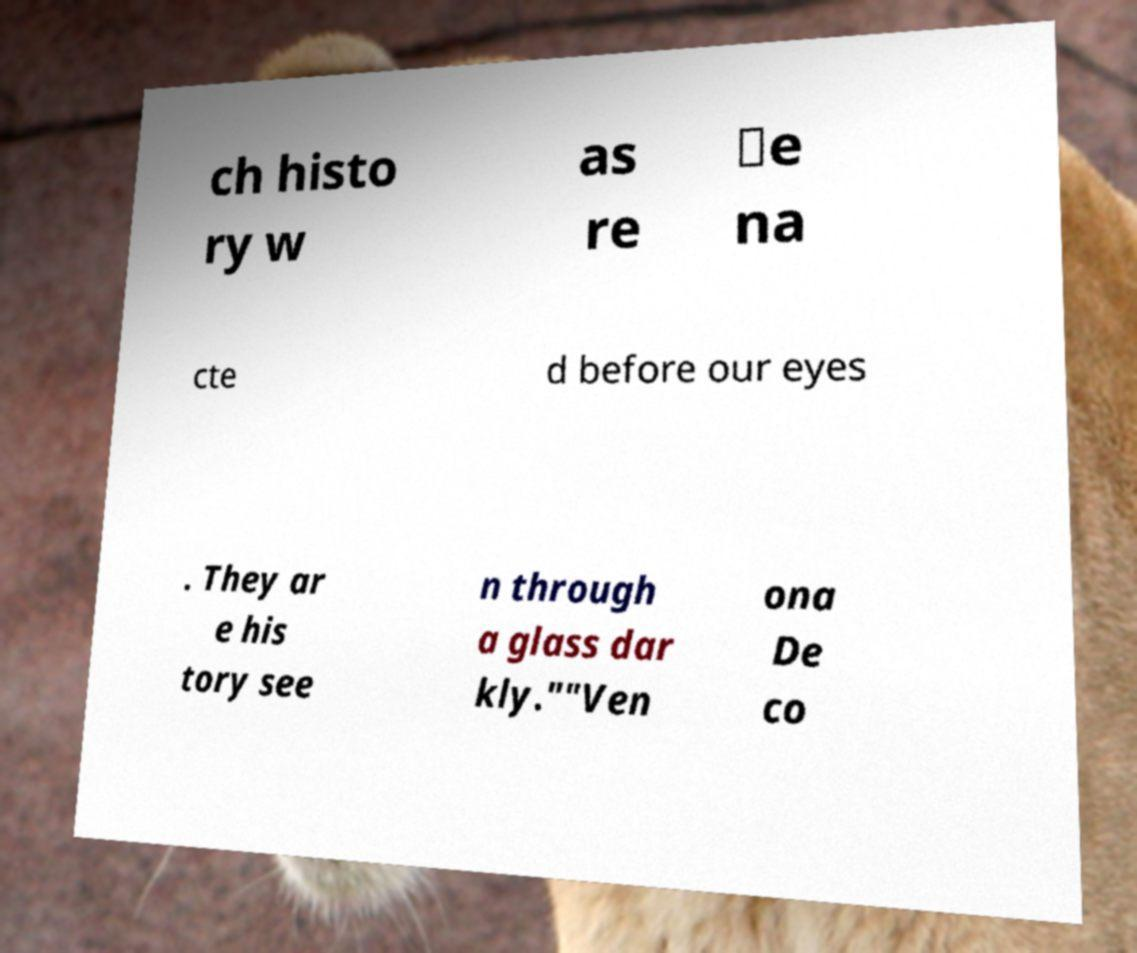Please read and relay the text visible in this image. What does it say? ch histo ry w as re ‑e na cte d before our eyes . They ar e his tory see n through a glass dar kly.""Ven ona De co 